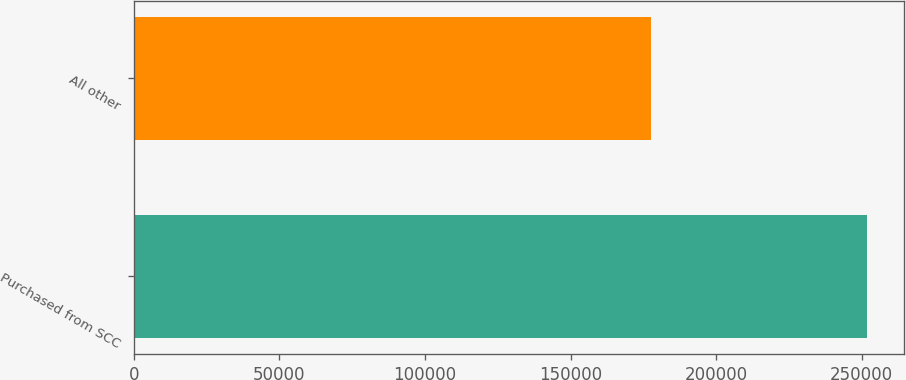<chart> <loc_0><loc_0><loc_500><loc_500><bar_chart><fcel>Purchased from SCC<fcel>All other<nl><fcel>251857<fcel>177455<nl></chart> 